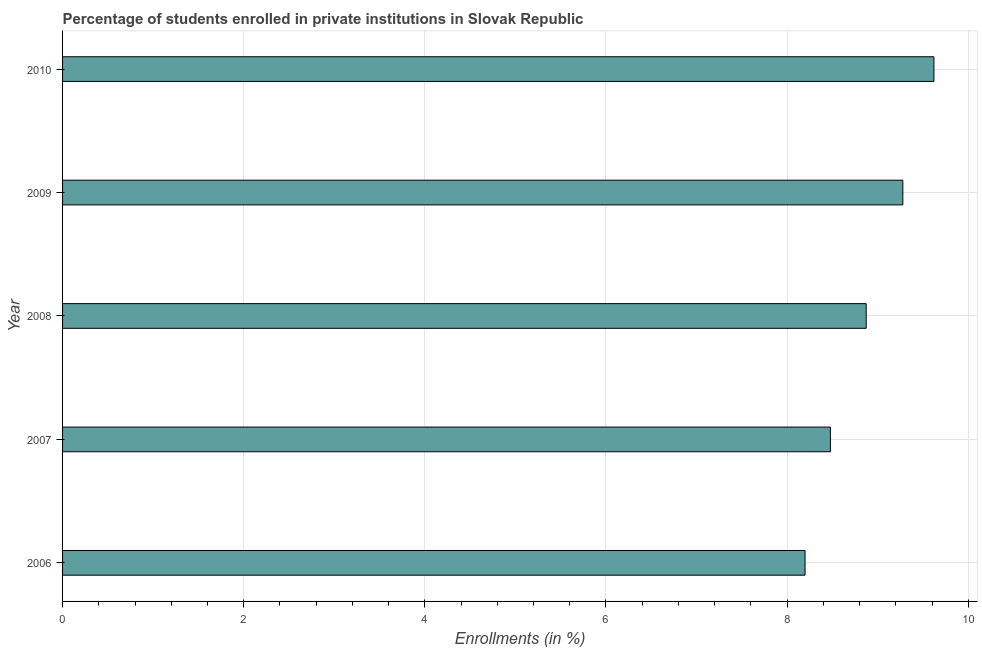Does the graph contain any zero values?
Offer a terse response. No. What is the title of the graph?
Offer a terse response. Percentage of students enrolled in private institutions in Slovak Republic. What is the label or title of the X-axis?
Offer a very short reply. Enrollments (in %). What is the label or title of the Y-axis?
Give a very brief answer. Year. What is the enrollments in private institutions in 2007?
Provide a short and direct response. 8.48. Across all years, what is the maximum enrollments in private institutions?
Make the answer very short. 9.62. Across all years, what is the minimum enrollments in private institutions?
Your answer should be very brief. 8.2. What is the sum of the enrollments in private institutions?
Give a very brief answer. 44.45. What is the difference between the enrollments in private institutions in 2006 and 2008?
Keep it short and to the point. -0.68. What is the average enrollments in private institutions per year?
Ensure brevity in your answer.  8.89. What is the median enrollments in private institutions?
Offer a terse response. 8.87. Do a majority of the years between 2007 and 2010 (inclusive) have enrollments in private institutions greater than 5.2 %?
Keep it short and to the point. Yes. What is the ratio of the enrollments in private institutions in 2006 to that in 2009?
Make the answer very short. 0.88. Is the enrollments in private institutions in 2007 less than that in 2008?
Offer a very short reply. Yes. Is the difference between the enrollments in private institutions in 2008 and 2010 greater than the difference between any two years?
Keep it short and to the point. No. What is the difference between the highest and the second highest enrollments in private institutions?
Provide a short and direct response. 0.34. What is the difference between the highest and the lowest enrollments in private institutions?
Provide a succinct answer. 1.42. How many bars are there?
Provide a short and direct response. 5. Are the values on the major ticks of X-axis written in scientific E-notation?
Ensure brevity in your answer.  No. What is the Enrollments (in %) in 2006?
Provide a short and direct response. 8.2. What is the Enrollments (in %) in 2007?
Make the answer very short. 8.48. What is the Enrollments (in %) in 2008?
Your answer should be very brief. 8.87. What is the Enrollments (in %) in 2009?
Provide a succinct answer. 9.28. What is the Enrollments (in %) in 2010?
Offer a very short reply. 9.62. What is the difference between the Enrollments (in %) in 2006 and 2007?
Your answer should be very brief. -0.28. What is the difference between the Enrollments (in %) in 2006 and 2008?
Offer a very short reply. -0.68. What is the difference between the Enrollments (in %) in 2006 and 2009?
Offer a very short reply. -1.08. What is the difference between the Enrollments (in %) in 2006 and 2010?
Provide a short and direct response. -1.42. What is the difference between the Enrollments (in %) in 2007 and 2008?
Offer a very short reply. -0.4. What is the difference between the Enrollments (in %) in 2007 and 2009?
Ensure brevity in your answer.  -0.8. What is the difference between the Enrollments (in %) in 2007 and 2010?
Your answer should be very brief. -1.14. What is the difference between the Enrollments (in %) in 2008 and 2009?
Ensure brevity in your answer.  -0.4. What is the difference between the Enrollments (in %) in 2008 and 2010?
Your answer should be compact. -0.75. What is the difference between the Enrollments (in %) in 2009 and 2010?
Keep it short and to the point. -0.34. What is the ratio of the Enrollments (in %) in 2006 to that in 2007?
Keep it short and to the point. 0.97. What is the ratio of the Enrollments (in %) in 2006 to that in 2008?
Offer a very short reply. 0.92. What is the ratio of the Enrollments (in %) in 2006 to that in 2009?
Provide a succinct answer. 0.88. What is the ratio of the Enrollments (in %) in 2006 to that in 2010?
Your answer should be compact. 0.85. What is the ratio of the Enrollments (in %) in 2007 to that in 2008?
Offer a very short reply. 0.95. What is the ratio of the Enrollments (in %) in 2007 to that in 2009?
Provide a short and direct response. 0.91. What is the ratio of the Enrollments (in %) in 2007 to that in 2010?
Provide a succinct answer. 0.88. What is the ratio of the Enrollments (in %) in 2008 to that in 2009?
Your answer should be very brief. 0.96. What is the ratio of the Enrollments (in %) in 2008 to that in 2010?
Your answer should be compact. 0.92. What is the ratio of the Enrollments (in %) in 2009 to that in 2010?
Provide a short and direct response. 0.96. 